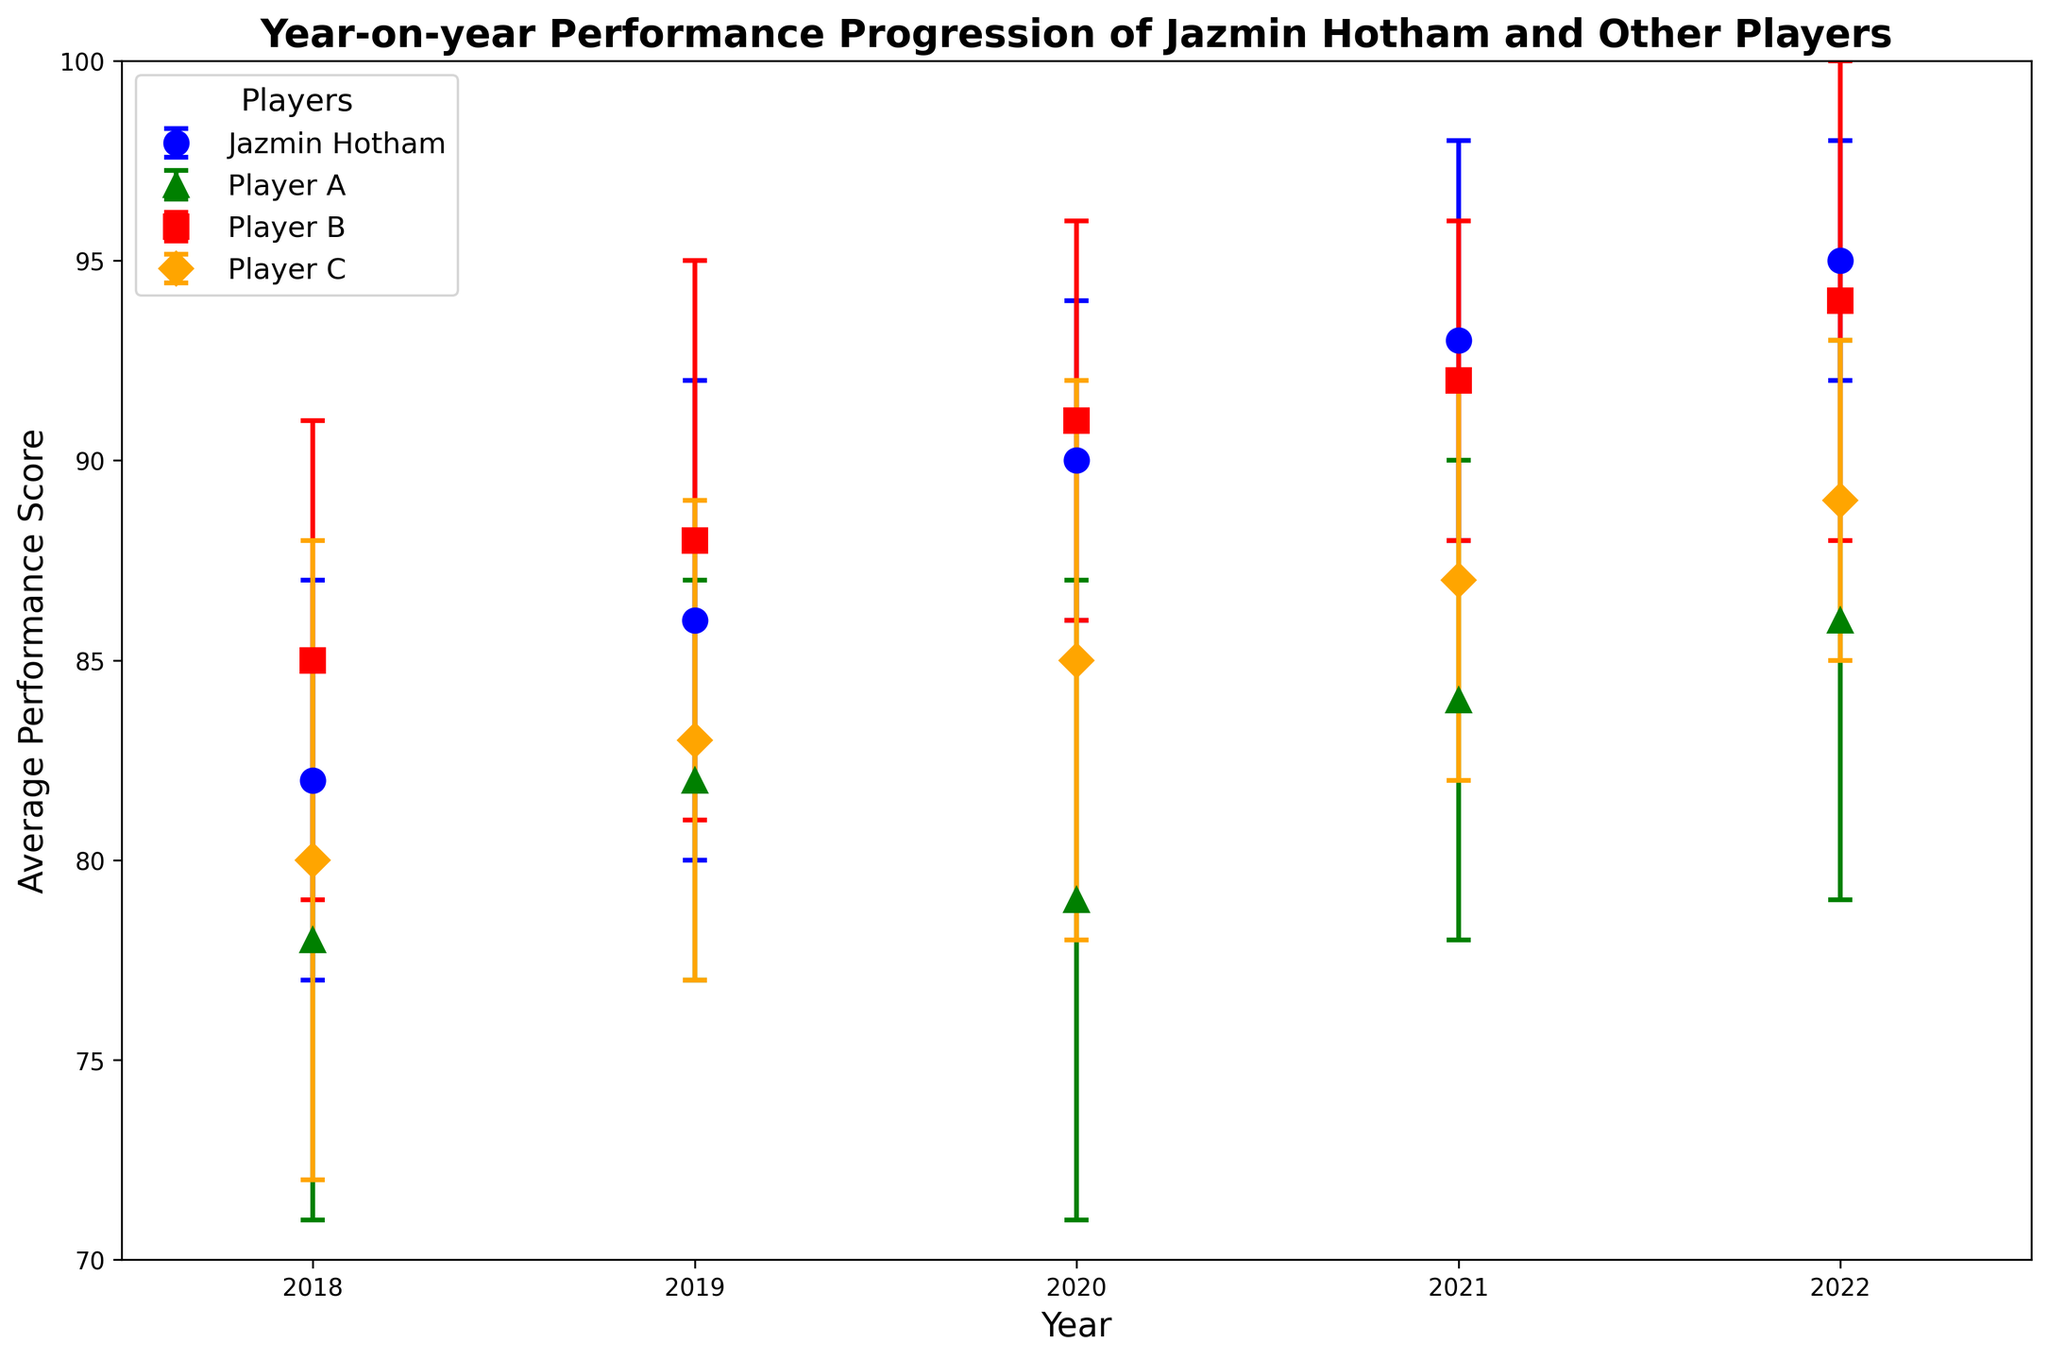Which player had the most consistent performance in 2022 based on the error bars? The consistency of performance is indicated by the length of the error bars. Shorter error bars represent more consistency. In 2022, Jazmin Hotham had the shortest error bars.
Answer: Jazmin Hotham In which year did Jazmin Hotham show the highest average performance score? By examining the trend of Jazmin Hotham's average performance scores over the years, the highest score is seen in 2022 with a score of 95.
Answer: 2022 How did Jazmin Hotham's average performance score compare to Player B's score in 2021? In 2021, Jazmin Hotham’s average performance score was 93, while Player B’s score was 92. Comparing the two, Jazmin Hotham had a higher score by 1 point.
Answer: Jazmin Hotham had a higher score by 1 point How did Player A’s performance consistency change from 2018 to 2019? To determine consistency changes, we look at the error bars’ length. In 2018, Player A had an error bar of 7, and in 2019, it was 5. This indicates improved consistency in 2019.
Answer: Improved consistency in 2019 Which player had the largest performance score improvement from 2018 to 2019? By checking the average performance scores for each player in 2018 and 2019, Player C improved from 80 to 83, showing a change of 3 points. The largest improvement among the players.
Answer: Player C How did Jazmin Hotham's performance consistency in 2018 compare to Player B’s performance consistency in 2022? Consistency is reflected by the error bars. In 2018, Jazmin Hotham's standard deviation was 5, while Player B’s in 2022 was 6. Thus, Jazmin Hotham was more consistent compared to Player B in 2022.
Answer: Jazmin Hotham was more consistent By how much did Jazmin Hotham’s average performance score increase from 2020 to 2021? Jazmin Hotham’s scores were 90 in 2020 and 93 in 2021. The increase is calculated as 93 - 90, which is 3 points.
Answer: 3 points What was the combined average performance score of Jazmin Hotham and Player A in 2019? In 2019, Jazmin Hotham had a score of 86 and Player A had 82. Adding these gives 86 + 82 = 168.
Answer: 168 How does the consistency of Player C's performance in 2022 compare to their consistency in 2020? Player C had a standard deviation of 4 in 2022 and 7 in 2020. The smaller the standard deviation, the more consistent the player. Thus, Player C was more consistent in 2022.
Answer: More consistent in 2022 Among the players, who had the highest average performance score in 2020? In 2020, Player B had the highest average performance score of 91.
Answer: Player B 